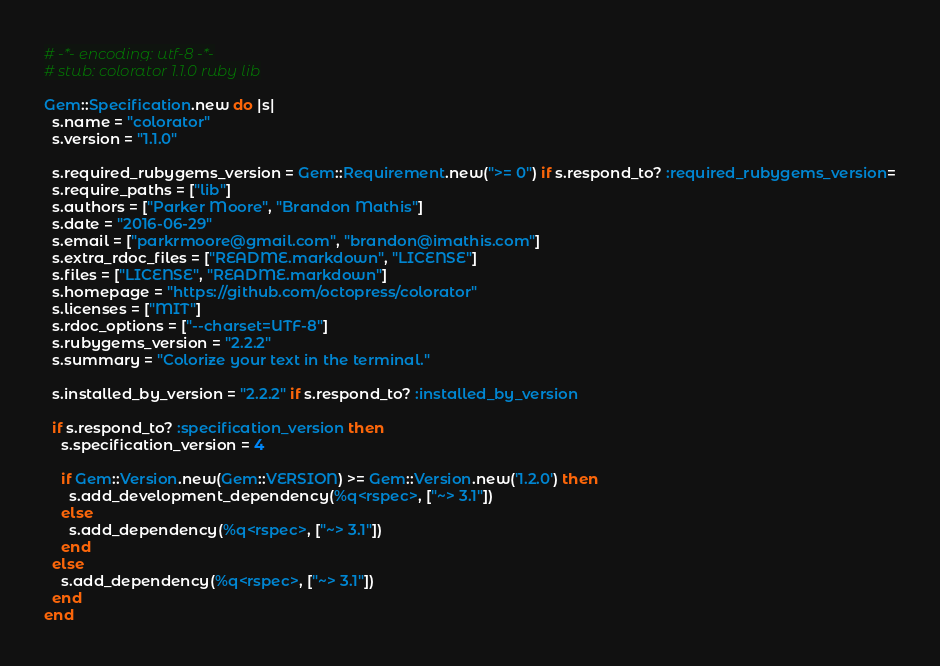Convert code to text. <code><loc_0><loc_0><loc_500><loc_500><_Ruby_># -*- encoding: utf-8 -*-
# stub: colorator 1.1.0 ruby lib

Gem::Specification.new do |s|
  s.name = "colorator"
  s.version = "1.1.0"

  s.required_rubygems_version = Gem::Requirement.new(">= 0") if s.respond_to? :required_rubygems_version=
  s.require_paths = ["lib"]
  s.authors = ["Parker Moore", "Brandon Mathis"]
  s.date = "2016-06-29"
  s.email = ["parkrmoore@gmail.com", "brandon@imathis.com"]
  s.extra_rdoc_files = ["README.markdown", "LICENSE"]
  s.files = ["LICENSE", "README.markdown"]
  s.homepage = "https://github.com/octopress/colorator"
  s.licenses = ["MIT"]
  s.rdoc_options = ["--charset=UTF-8"]
  s.rubygems_version = "2.2.2"
  s.summary = "Colorize your text in the terminal."

  s.installed_by_version = "2.2.2" if s.respond_to? :installed_by_version

  if s.respond_to? :specification_version then
    s.specification_version = 4

    if Gem::Version.new(Gem::VERSION) >= Gem::Version.new('1.2.0') then
      s.add_development_dependency(%q<rspec>, ["~> 3.1"])
    else
      s.add_dependency(%q<rspec>, ["~> 3.1"])
    end
  else
    s.add_dependency(%q<rspec>, ["~> 3.1"])
  end
end
</code> 